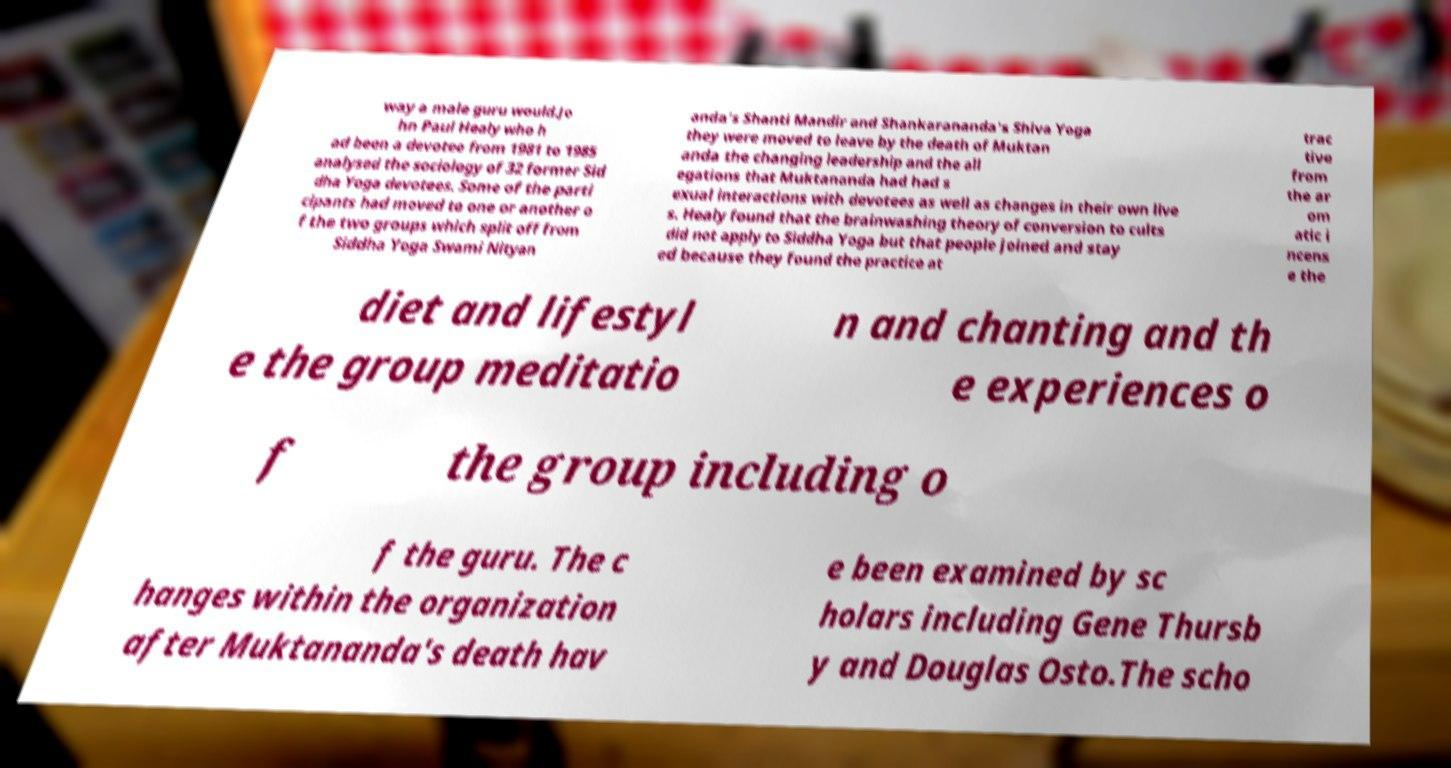Could you extract and type out the text from this image? way a male guru would.Jo hn Paul Healy who h ad been a devotee from 1981 to 1985 analysed the sociology of 32 former Sid dha Yoga devotees. Some of the parti cipants had moved to one or another o f the two groups which split off from Siddha Yoga Swami Nityan anda's Shanti Mandir and Shankarananda's Shiva Yoga they were moved to leave by the death of Muktan anda the changing leadership and the all egations that Muktananda had had s exual interactions with devotees as well as changes in their own live s. Healy found that the brainwashing theory of conversion to cults did not apply to Siddha Yoga but that people joined and stay ed because they found the practice at trac tive from the ar om atic i ncens e the diet and lifestyl e the group meditatio n and chanting and th e experiences o f the group including o f the guru. The c hanges within the organization after Muktananda's death hav e been examined by sc holars including Gene Thursb y and Douglas Osto.The scho 